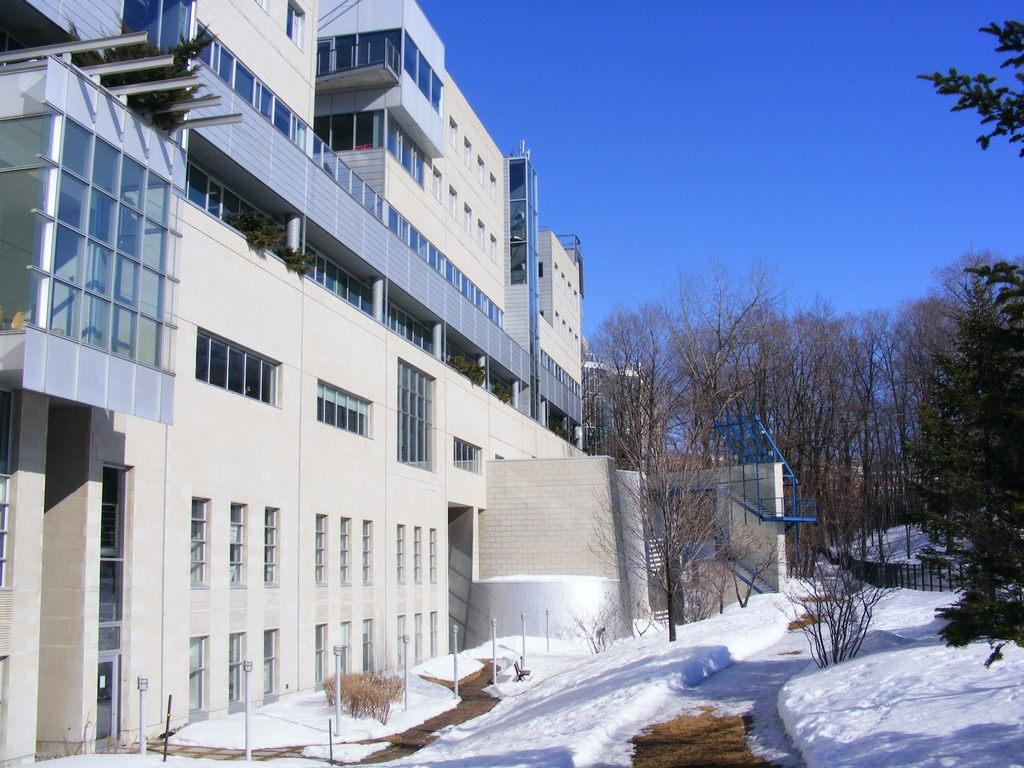What is the weather like in the image? There is snow in the image, indicating a cold and wintry scene. What structure is located on the left side of the image? There is a white building on the left side of the image. What can be seen in the image besides the building? There is a fence and trees in the background visible in the image. What is visible at the top of the image? The sky is visible at the top of the image. Can you see a bridge in the image? There is no bridge present in the image. Is there a pot visible in the image? There is no pot visible in the image. 